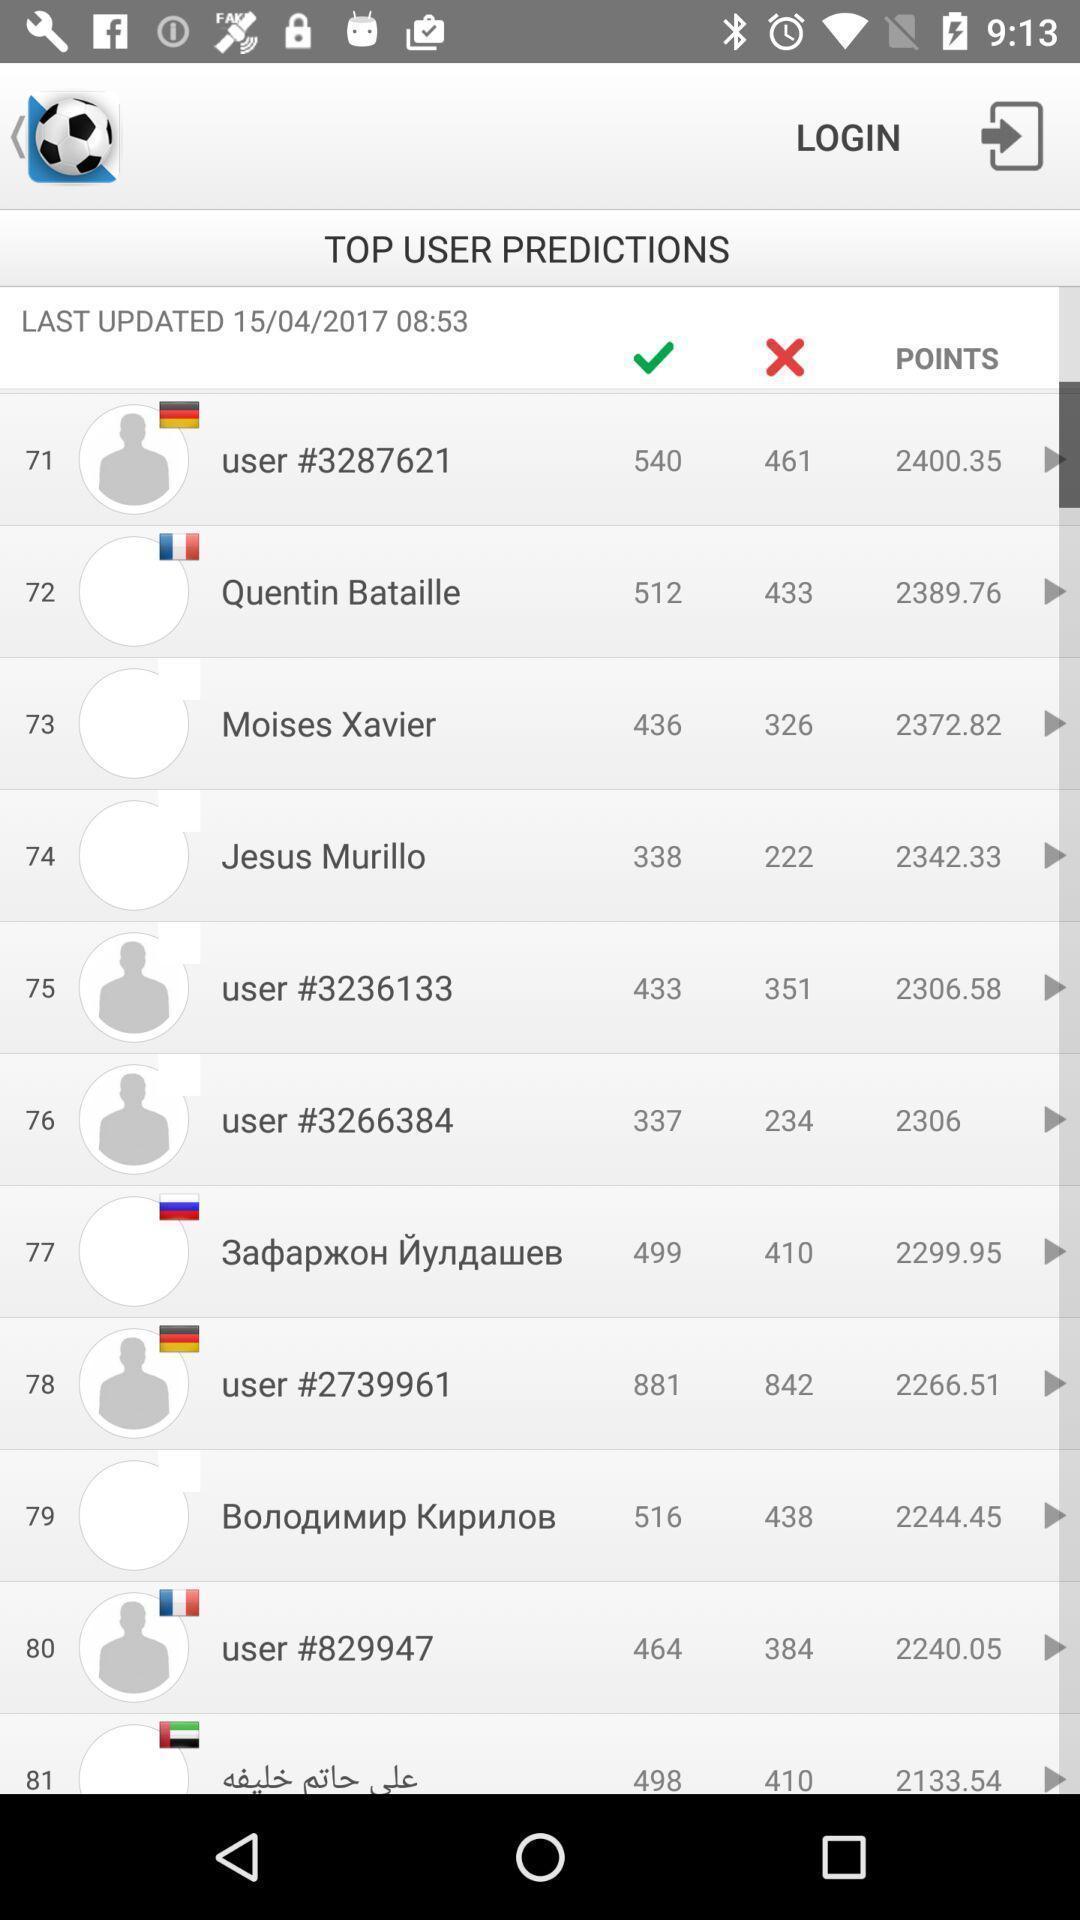Tell me what you see in this picture. Page that displaying sports application. 